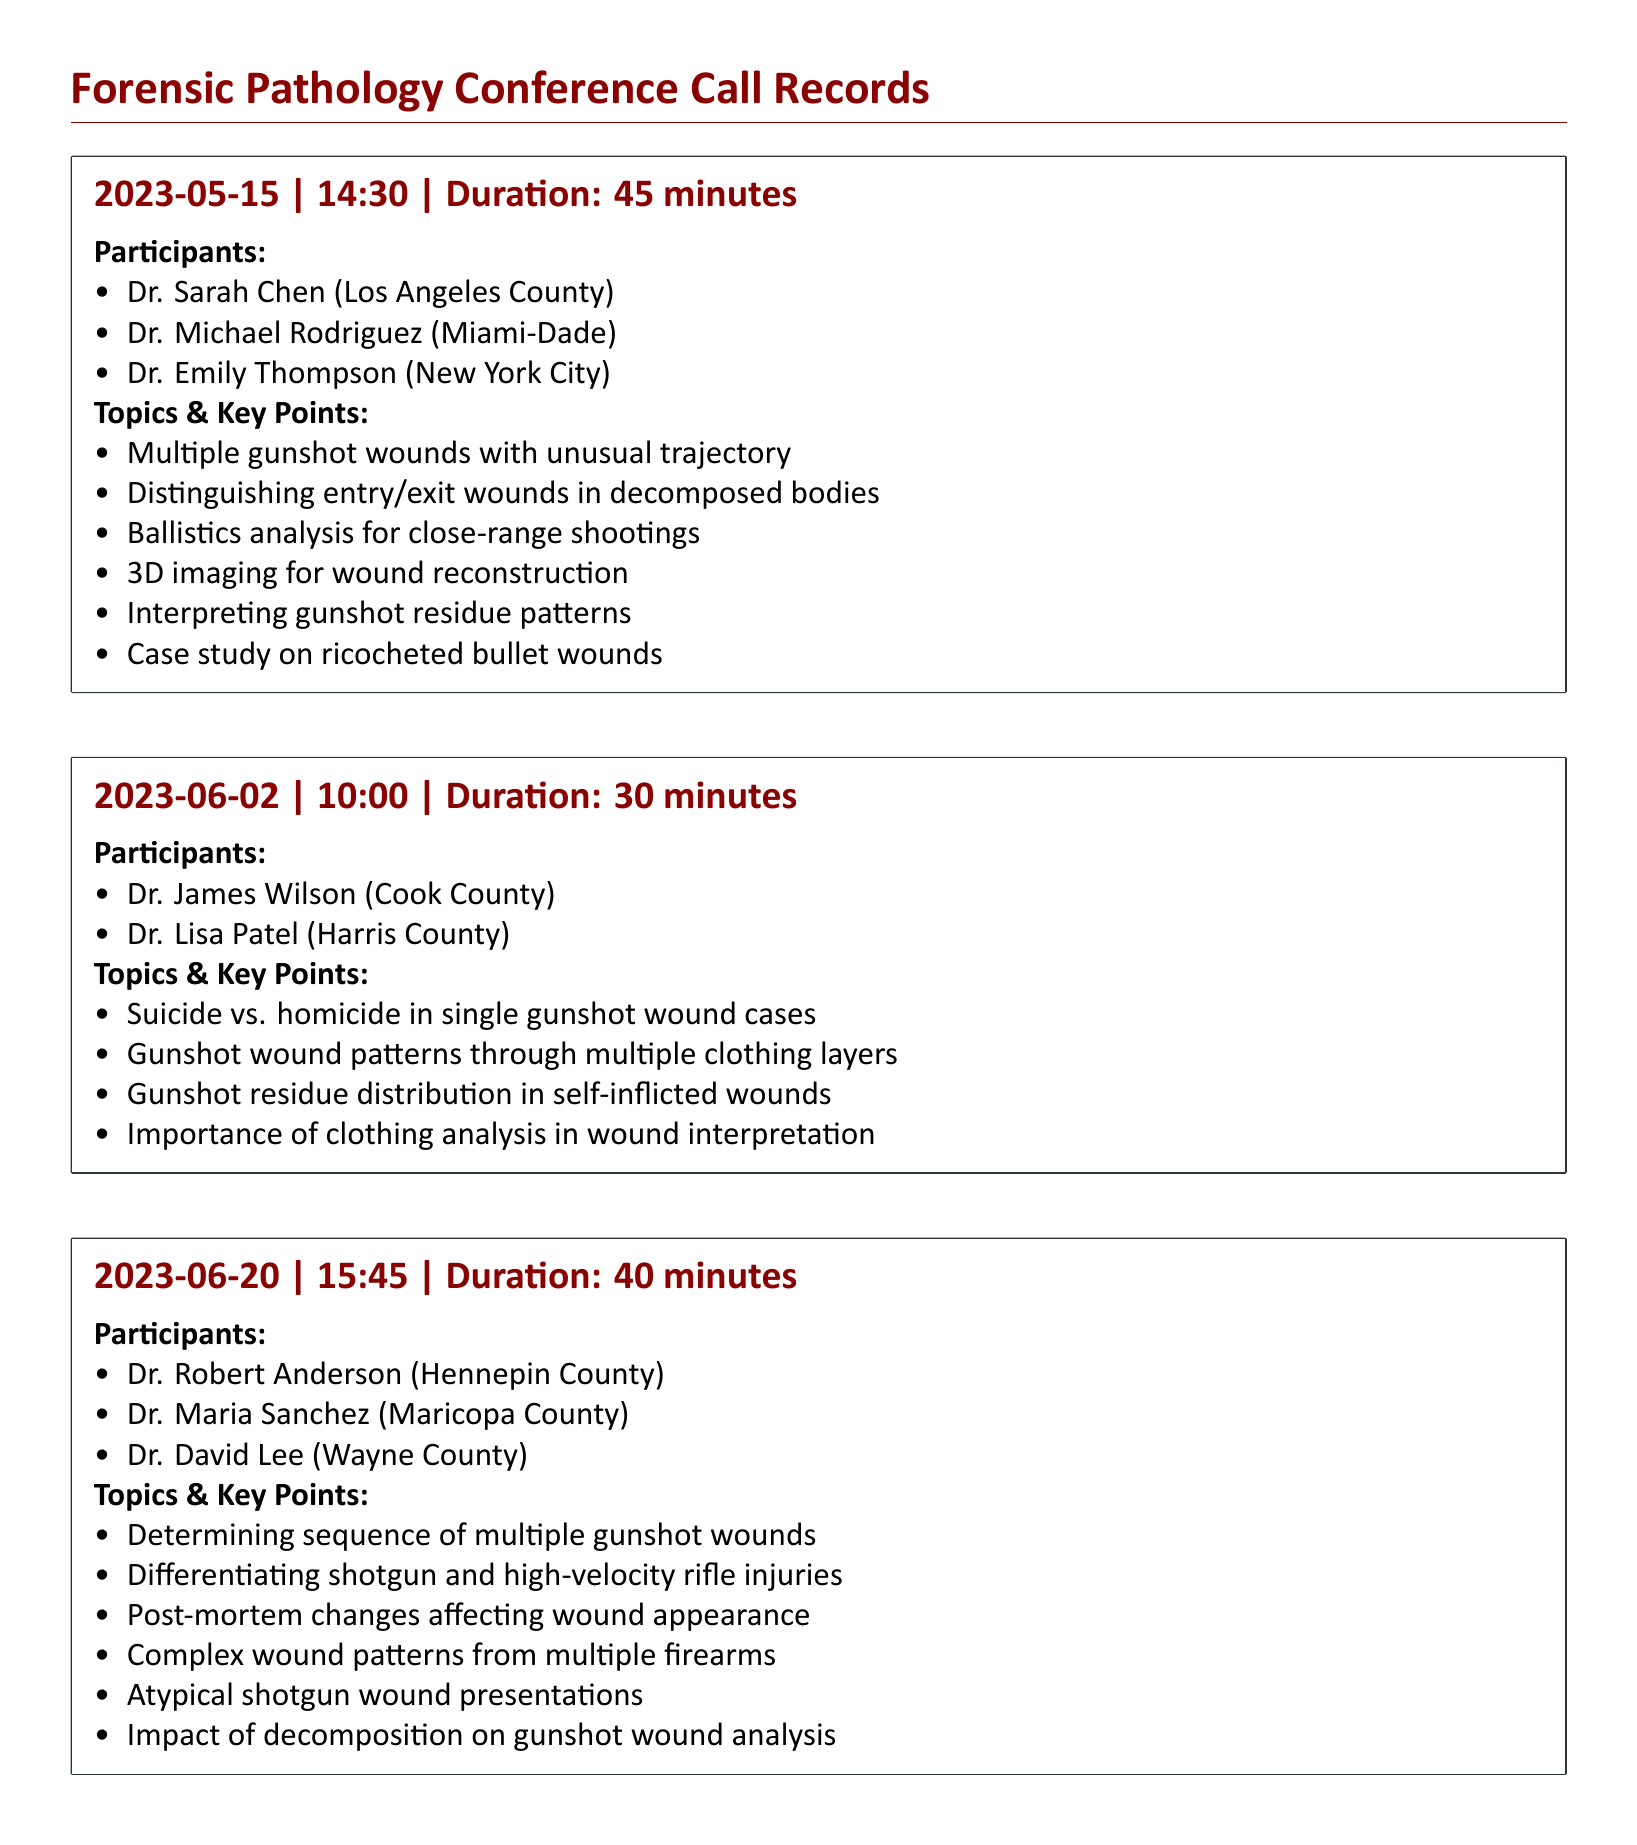what is the date of the first conference call? The date of the first conference call can be found in the first record, which notes the date as 2023-05-15.
Answer: 2023-05-15 how long was the call on June 2, 2023? The duration of the call on June 2, 2023, is specified in the second record as 30 minutes.
Answer: 30 minutes who participated in the call on June 20, 2023? The participants for the June 20, 2023, call are listed in the third record, which mentions Dr. Robert Anderson, Dr. Maria Sanchez, and Dr. David Lee.
Answer: Dr. Robert Anderson, Dr. Maria Sanchez, Dr. David Lee what was one of the topics discussed in the first call? The topics discussed in the first call include various key points, one of which is 'Multiple gunshot wounds with unusual trajectory'.
Answer: Multiple gunshot wounds with unusual trajectory which county is Dr. Sarah Chen associated with? Dr. Sarah Chen is mentioned as being from Los Angeles County in the participants list of the first call.
Answer: Los Angeles County how many minutes was the call on May 15, 2023? The duration of the call on May 15, 2023, is noted as 45 minutes.
Answer: 45 minutes what is one key point discussed regarding gunshot wounds in the third call? The third call discusses several topics; one key point is about 'Differentiating shotgun and high-velocity rifle injuries'.
Answer: Differentiating shotgun and high-velocity rifle injuries which forensic analysis method was highlighted in the first conference call? One of the methods discussed in the first call is '3D imaging for wound reconstruction'.
Answer: 3D imaging for wound reconstruction what case type was addressed in the second conference call? The second call specifically addressed the distinction between suicide and homicide in gunshot wound cases.
Answer: Suicide vs. homicide in single gunshot wound cases 